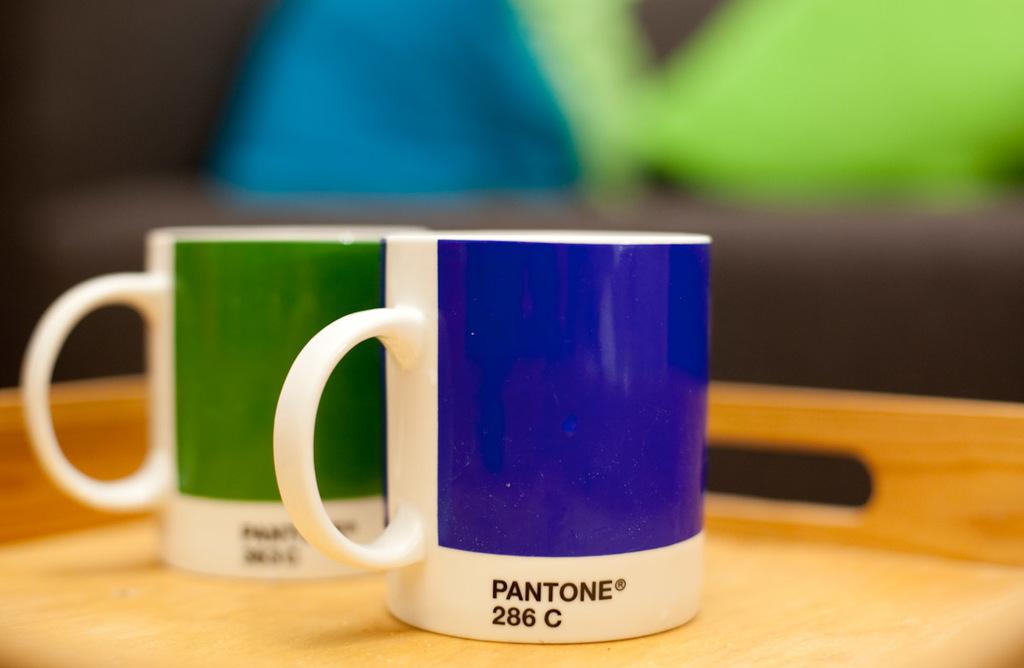What is written on the blue/white mug?
Offer a terse response. Pantone 286 c. What colors are the mugs?
Provide a succinct answer. Answering does not require reading text in the image. 